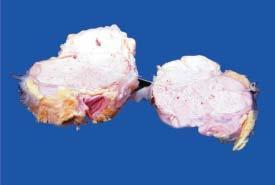where did etastatic carcinomatous deposit?
Answer the question using a single word or phrase. In the mat mass of lymph nodes 